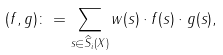<formula> <loc_0><loc_0><loc_500><loc_500>( f , g ) \colon = \sum _ { { s } \in \widehat { S } _ { i } ( X ) } w ( s ) \cdot f ( s ) \cdot g ( s ) ,</formula> 